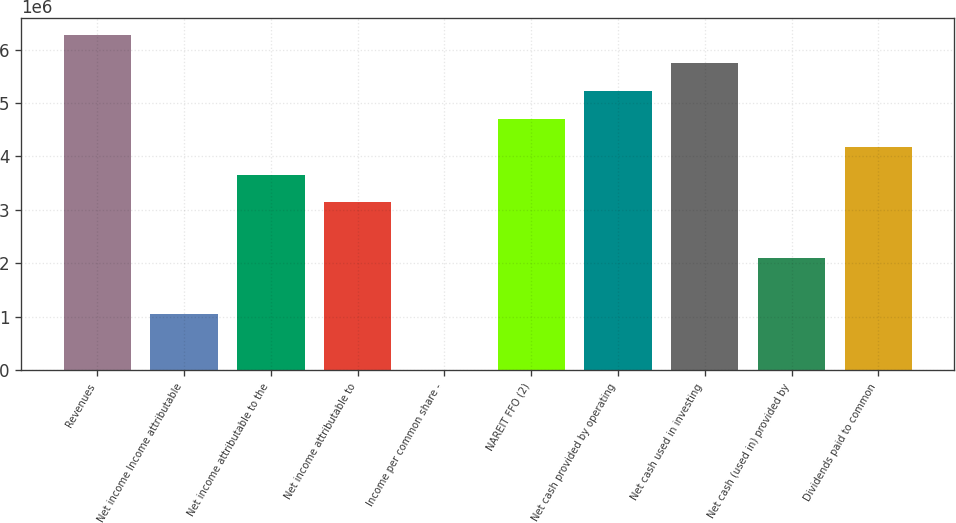Convert chart. <chart><loc_0><loc_0><loc_500><loc_500><bar_chart><fcel>Revenues<fcel>Net income Income attributable<fcel>Net income attributable to the<fcel>Net income attributable to<fcel>Income per common share -<fcel>NAREIT FFO (2)<fcel>Net cash provided by operating<fcel>Net cash used in investing<fcel>Net cash (used in) provided by<fcel>Dividends paid to common<nl><fcel>6.27624e+06<fcel>1.04604e+06<fcel>3.66114e+06<fcel>3.13812e+06<fcel>1.42<fcel>4.70718e+06<fcel>5.2302e+06<fcel>5.75322e+06<fcel>2.09208e+06<fcel>4.18416e+06<nl></chart> 